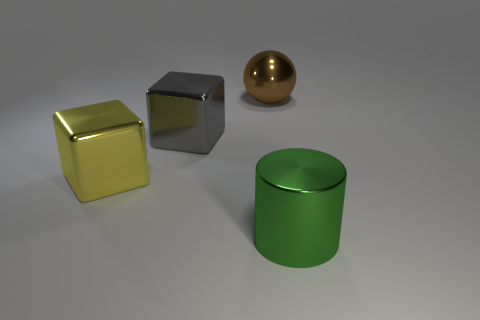Subtract 1 cylinders. How many cylinders are left? 0 Add 2 purple balls. How many purple balls exist? 2 Add 3 gray cubes. How many objects exist? 7 Subtract 0 red balls. How many objects are left? 4 Subtract all yellow cubes. Subtract all gray cylinders. How many cubes are left? 1 Subtract all brown blocks. How many cyan cylinders are left? 0 Subtract all brown metal things. Subtract all tiny purple matte objects. How many objects are left? 3 Add 4 big yellow cubes. How many big yellow cubes are left? 5 